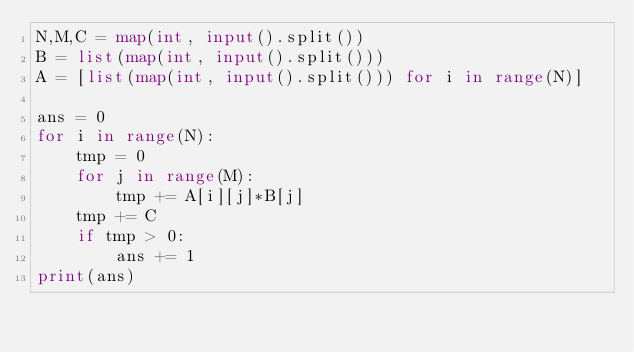<code> <loc_0><loc_0><loc_500><loc_500><_Python_>N,M,C = map(int, input().split())
B = list(map(int, input().split()))
A = [list(map(int, input().split())) for i in range(N)]

ans = 0
for i in range(N):
    tmp = 0
    for j in range(M):
        tmp += A[i][j]*B[j]
    tmp += C
    if tmp > 0:
        ans += 1
print(ans)</code> 